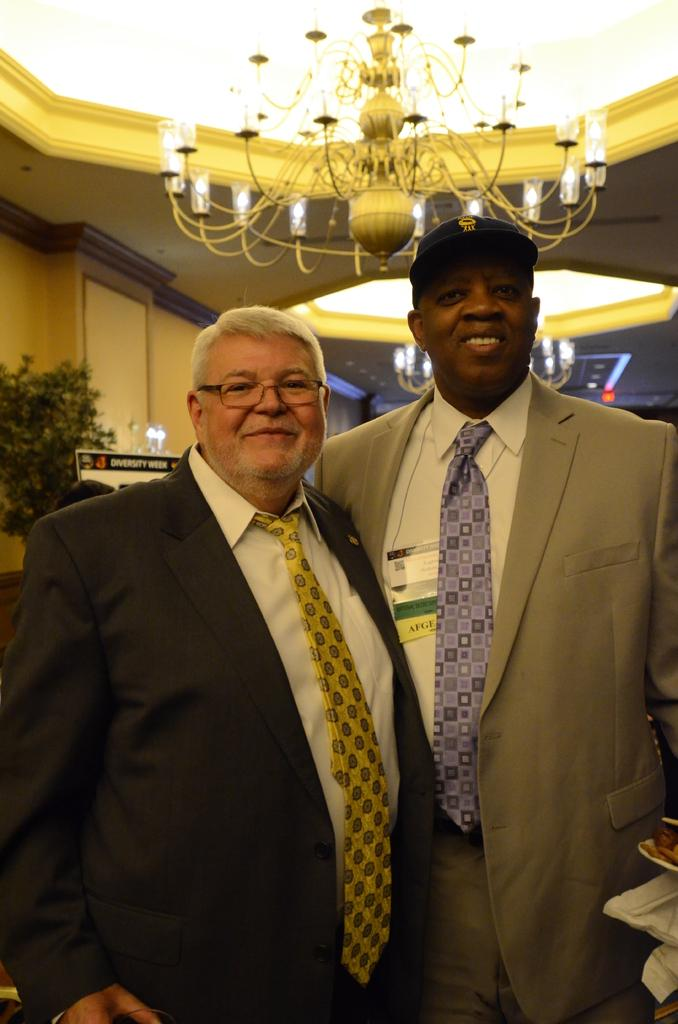How many people are in the image? There are two people standing in the image. What is the facial expression of the people in the image? The people are smiling. What can be seen in the background of the image? There is a chandelier, a board, a plant, and a wall in the background of the image. What type of police face can be seen in the image? There is no police face present in the image. How does the earthquake affect the people in the image? There is no earthquake depicted in the image, so its effects cannot be determined. 